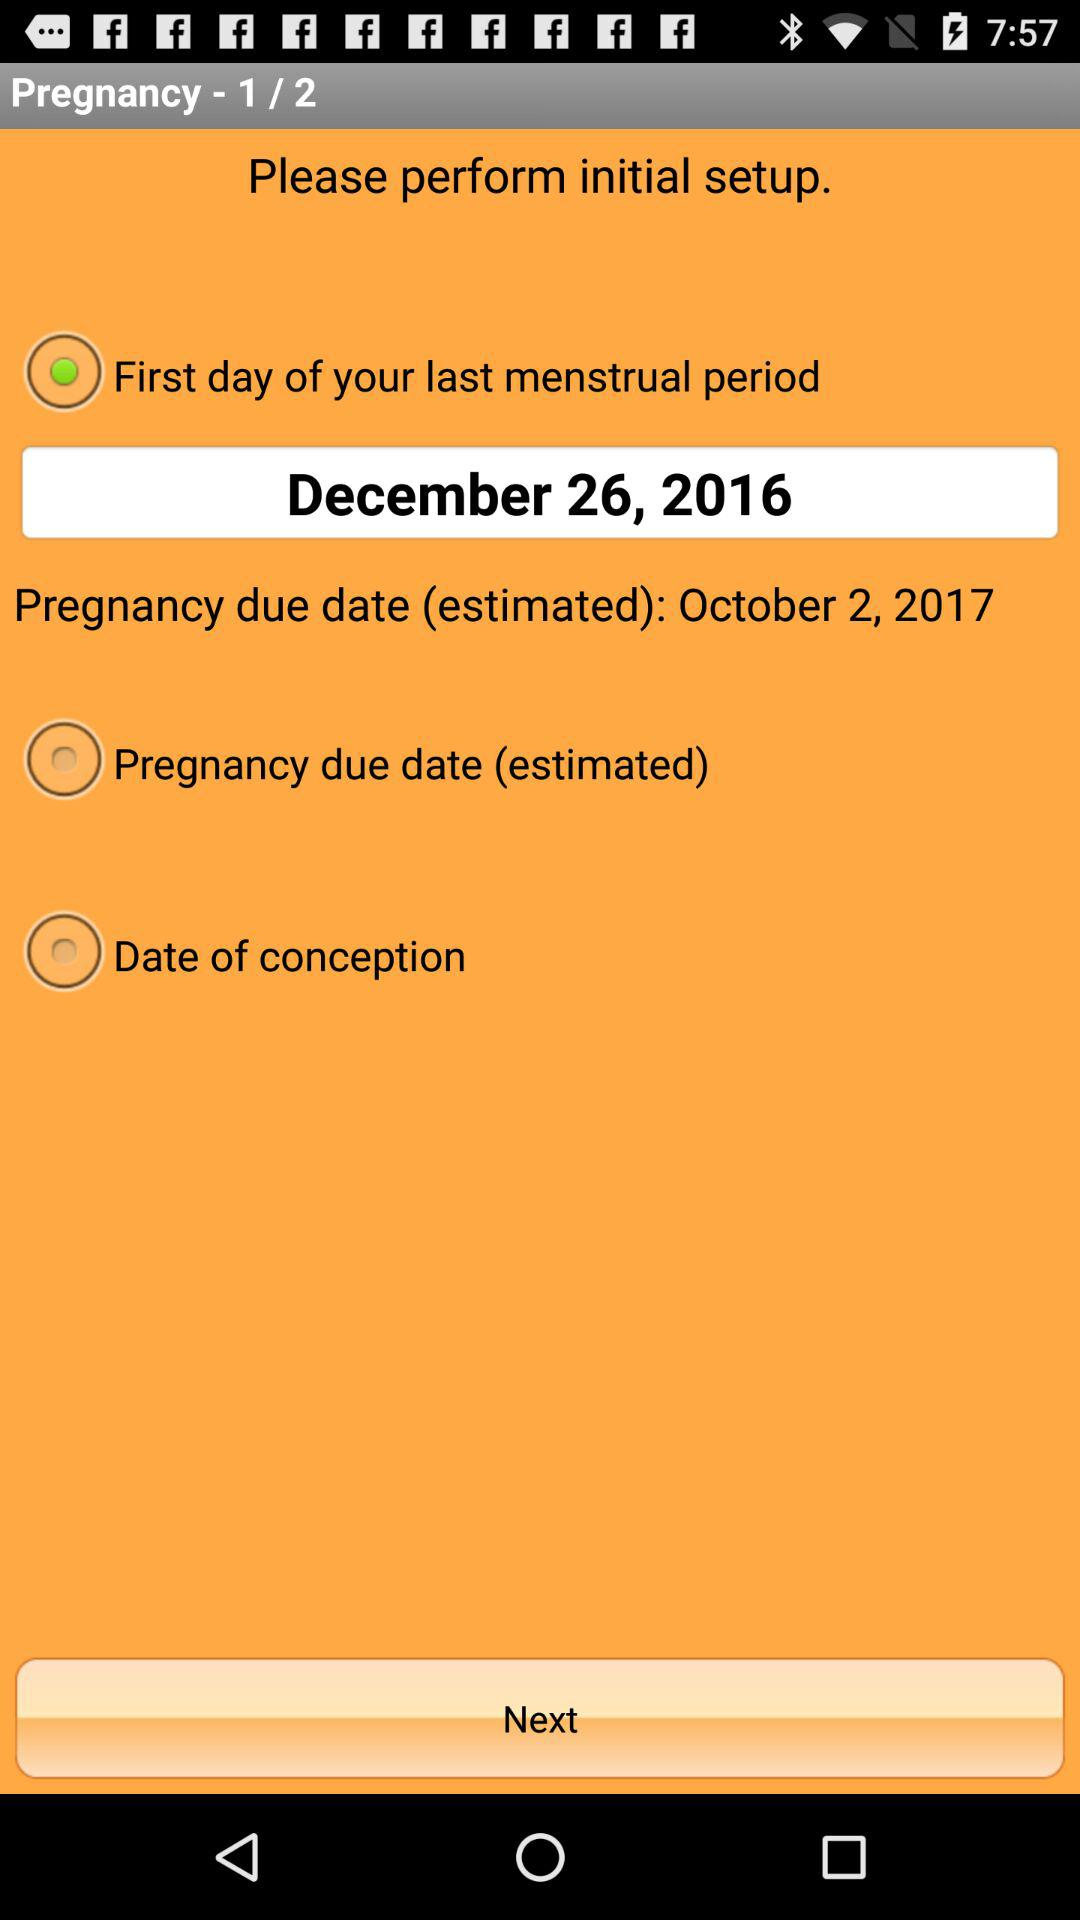What is the status of "Date of conception"? The status is "off". 